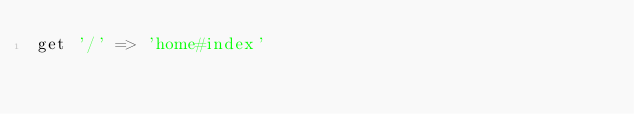Convert code to text. <code><loc_0><loc_0><loc_500><loc_500><_JavaScript_>get '/' => 'home#index'
</code> 